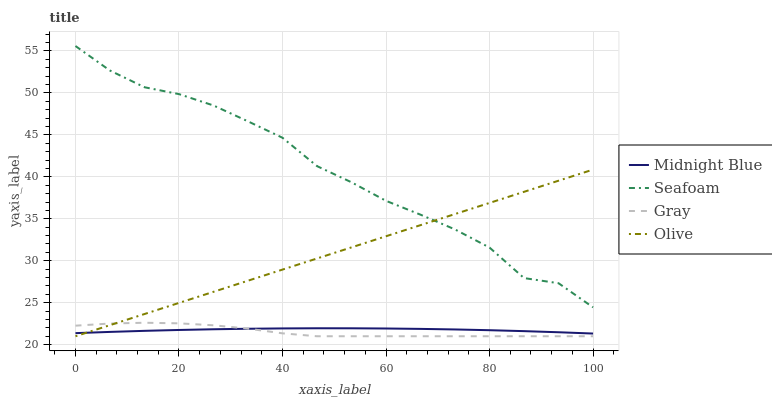Does Gray have the minimum area under the curve?
Answer yes or no. Yes. Does Seafoam have the maximum area under the curve?
Answer yes or no. Yes. Does Midnight Blue have the minimum area under the curve?
Answer yes or no. No. Does Midnight Blue have the maximum area under the curve?
Answer yes or no. No. Is Olive the smoothest?
Answer yes or no. Yes. Is Seafoam the roughest?
Answer yes or no. Yes. Is Gray the smoothest?
Answer yes or no. No. Is Gray the roughest?
Answer yes or no. No. Does Olive have the lowest value?
Answer yes or no. Yes. Does Midnight Blue have the lowest value?
Answer yes or no. No. Does Seafoam have the highest value?
Answer yes or no. Yes. Does Gray have the highest value?
Answer yes or no. No. Is Gray less than Seafoam?
Answer yes or no. Yes. Is Seafoam greater than Midnight Blue?
Answer yes or no. Yes. Does Olive intersect Seafoam?
Answer yes or no. Yes. Is Olive less than Seafoam?
Answer yes or no. No. Is Olive greater than Seafoam?
Answer yes or no. No. Does Gray intersect Seafoam?
Answer yes or no. No. 